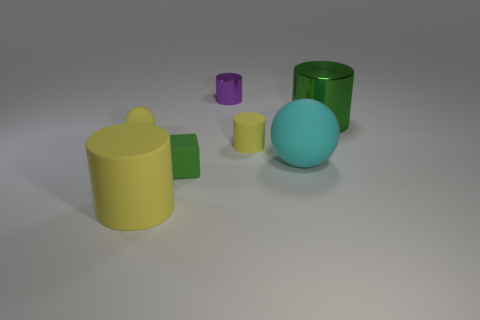Subtract all red cylinders. Subtract all yellow cubes. How many cylinders are left? 4 Add 2 green cylinders. How many objects exist? 9 Subtract all cubes. How many objects are left? 6 Add 2 large purple metallic balls. How many large purple metallic balls exist? 2 Subtract 0 brown cubes. How many objects are left? 7 Subtract all brown metallic things. Subtract all large cyan spheres. How many objects are left? 6 Add 2 big cyan matte balls. How many big cyan matte balls are left? 3 